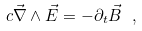Convert formula to latex. <formula><loc_0><loc_0><loc_500><loc_500>c \vec { \nabla } \land \vec { E } = - \partial _ { t } \vec { B } \ ,</formula> 